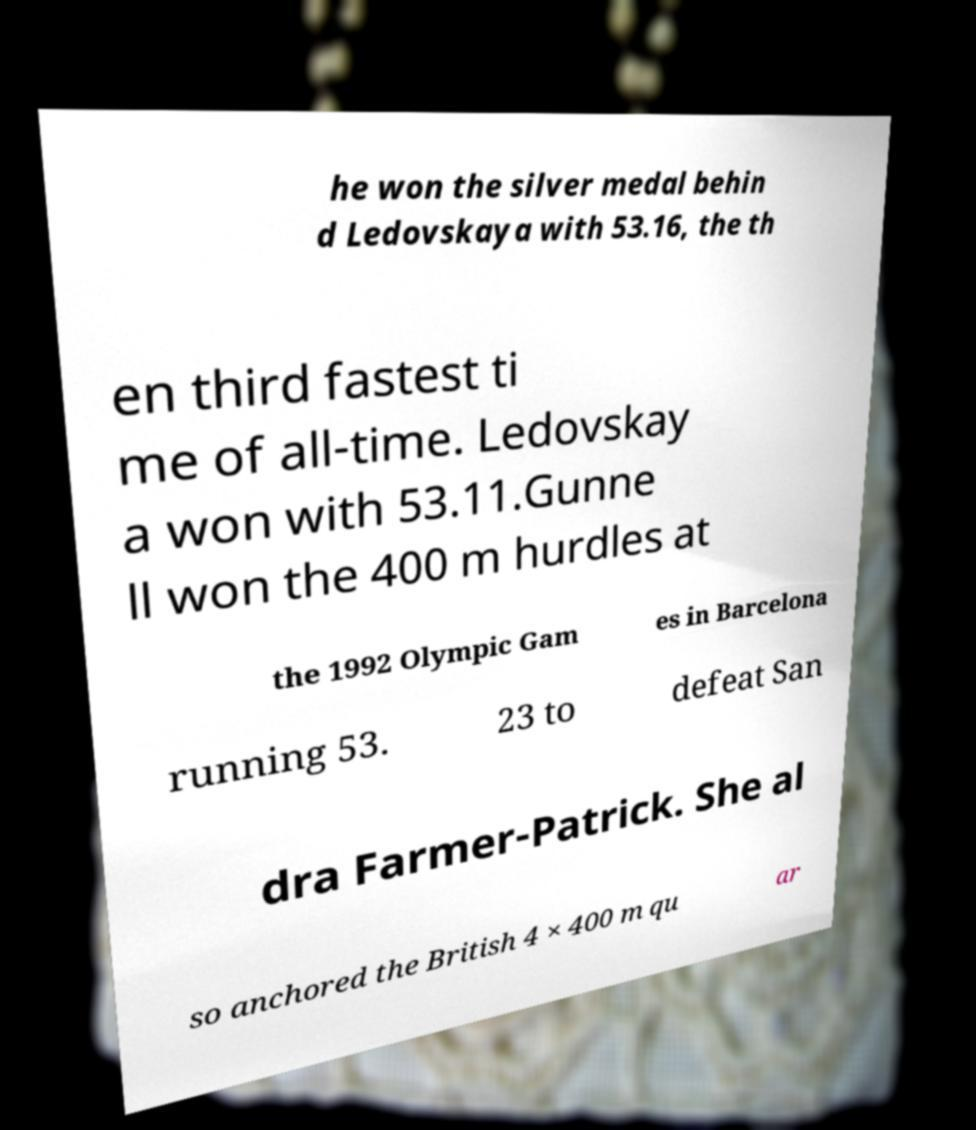For documentation purposes, I need the text within this image transcribed. Could you provide that? he won the silver medal behin d Ledovskaya with 53.16, the th en third fastest ti me of all-time. Ledovskay a won with 53.11.Gunne ll won the 400 m hurdles at the 1992 Olympic Gam es in Barcelona running 53. 23 to defeat San dra Farmer-Patrick. She al so anchored the British 4 × 400 m qu ar 